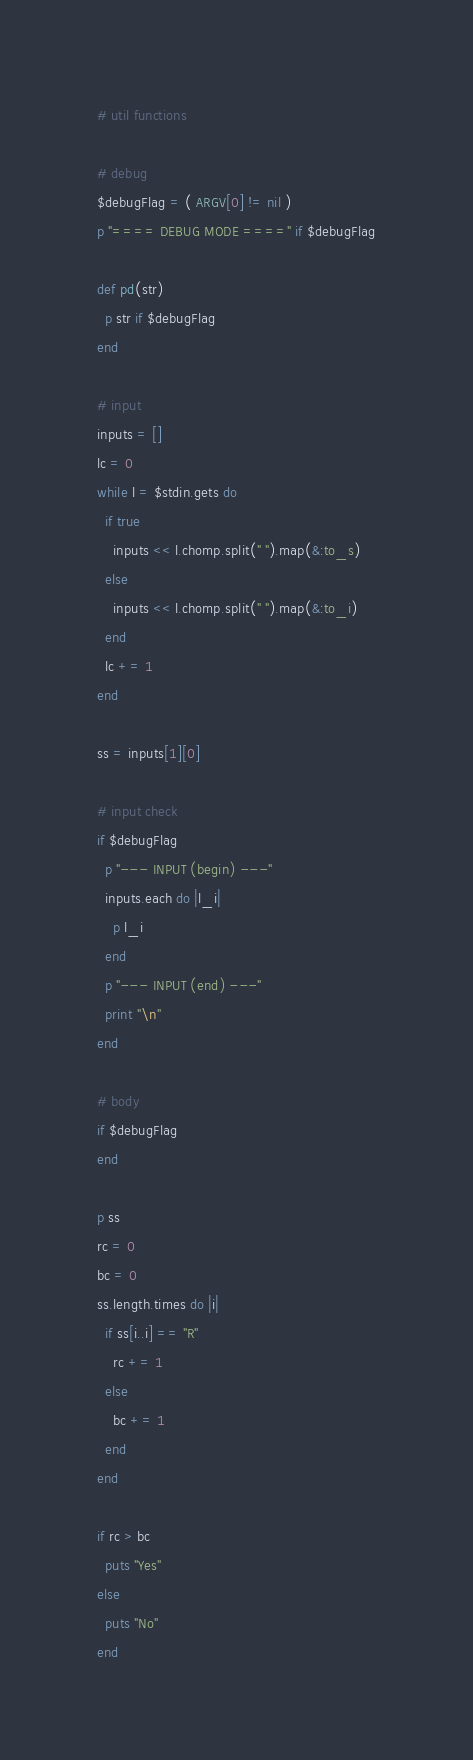<code> <loc_0><loc_0><loc_500><loc_500><_Ruby_># util functions

# debug
$debugFlag = ( ARGV[0] != nil )
p "==== DEBUG MODE ====" if $debugFlag

def pd(str)
  p str if $debugFlag
end

# input
inputs = []
lc = 0
while l = $stdin.gets do
  if true
    inputs << l.chomp.split(" ").map(&:to_s)
  else
    inputs << l.chomp.split(" ").map(&:to_i)
  end
  lc += 1
end

ss = inputs[1][0]

# input check
if $debugFlag
  p "--- INPUT (begin) ---"
  inputs.each do |l_i|
    p l_i
  end
  p "--- INPUT (end) ---"
  print "\n"
end

# body
if $debugFlag
end

p ss
rc = 0
bc = 0
ss.length.times do |i|
  if ss[i..i] == "R"
    rc += 1
  else
    bc += 1
  end
end

if rc > bc
  puts "Yes"
else
  puts "No"
end
</code> 